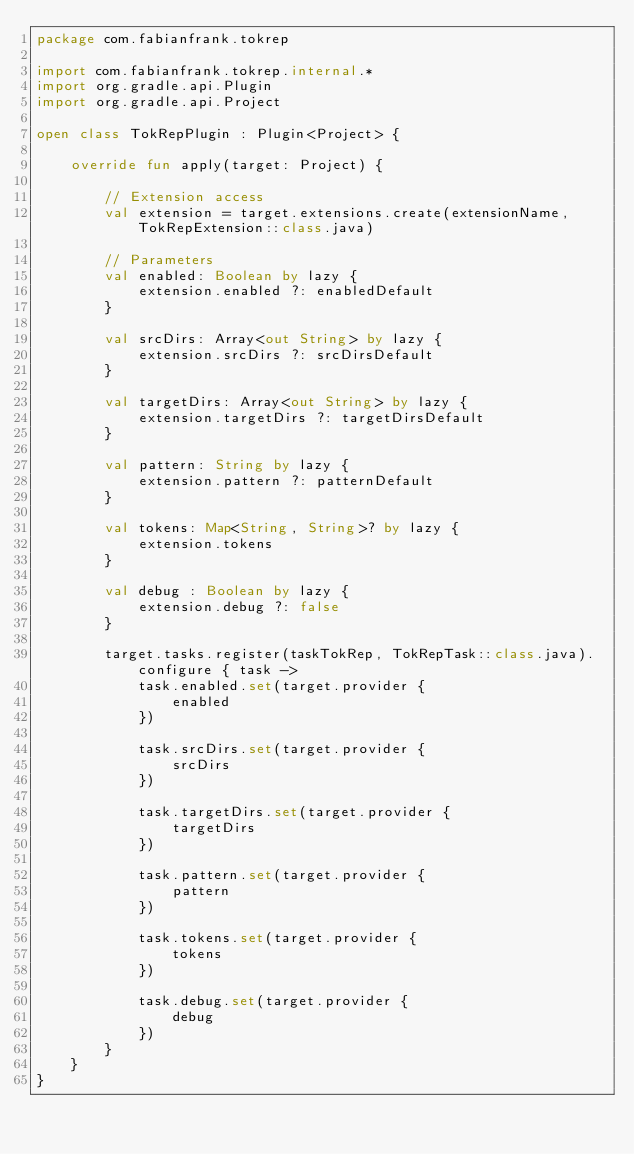<code> <loc_0><loc_0><loc_500><loc_500><_Kotlin_>package com.fabianfrank.tokrep

import com.fabianfrank.tokrep.internal.*
import org.gradle.api.Plugin
import org.gradle.api.Project

open class TokRepPlugin : Plugin<Project> {

    override fun apply(target: Project) {

        // Extension access
        val extension = target.extensions.create(extensionName, TokRepExtension::class.java)

        // Parameters
        val enabled: Boolean by lazy {
            extension.enabled ?: enabledDefault
        }

        val srcDirs: Array<out String> by lazy {
            extension.srcDirs ?: srcDirsDefault
        }

        val targetDirs: Array<out String> by lazy {
            extension.targetDirs ?: targetDirsDefault
        }

        val pattern: String by lazy {
            extension.pattern ?: patternDefault
        }

        val tokens: Map<String, String>? by lazy {
            extension.tokens
        }

        val debug : Boolean by lazy {
            extension.debug ?: false
        }

        target.tasks.register(taskTokRep, TokRepTask::class.java).configure { task ->
            task.enabled.set(target.provider {
                enabled
            })

            task.srcDirs.set(target.provider {
                srcDirs
            })

            task.targetDirs.set(target.provider {
                targetDirs
            })

            task.pattern.set(target.provider {
                pattern
            })

            task.tokens.set(target.provider {
                tokens
            })

            task.debug.set(target.provider {
                debug
            })
        }
    }
}</code> 